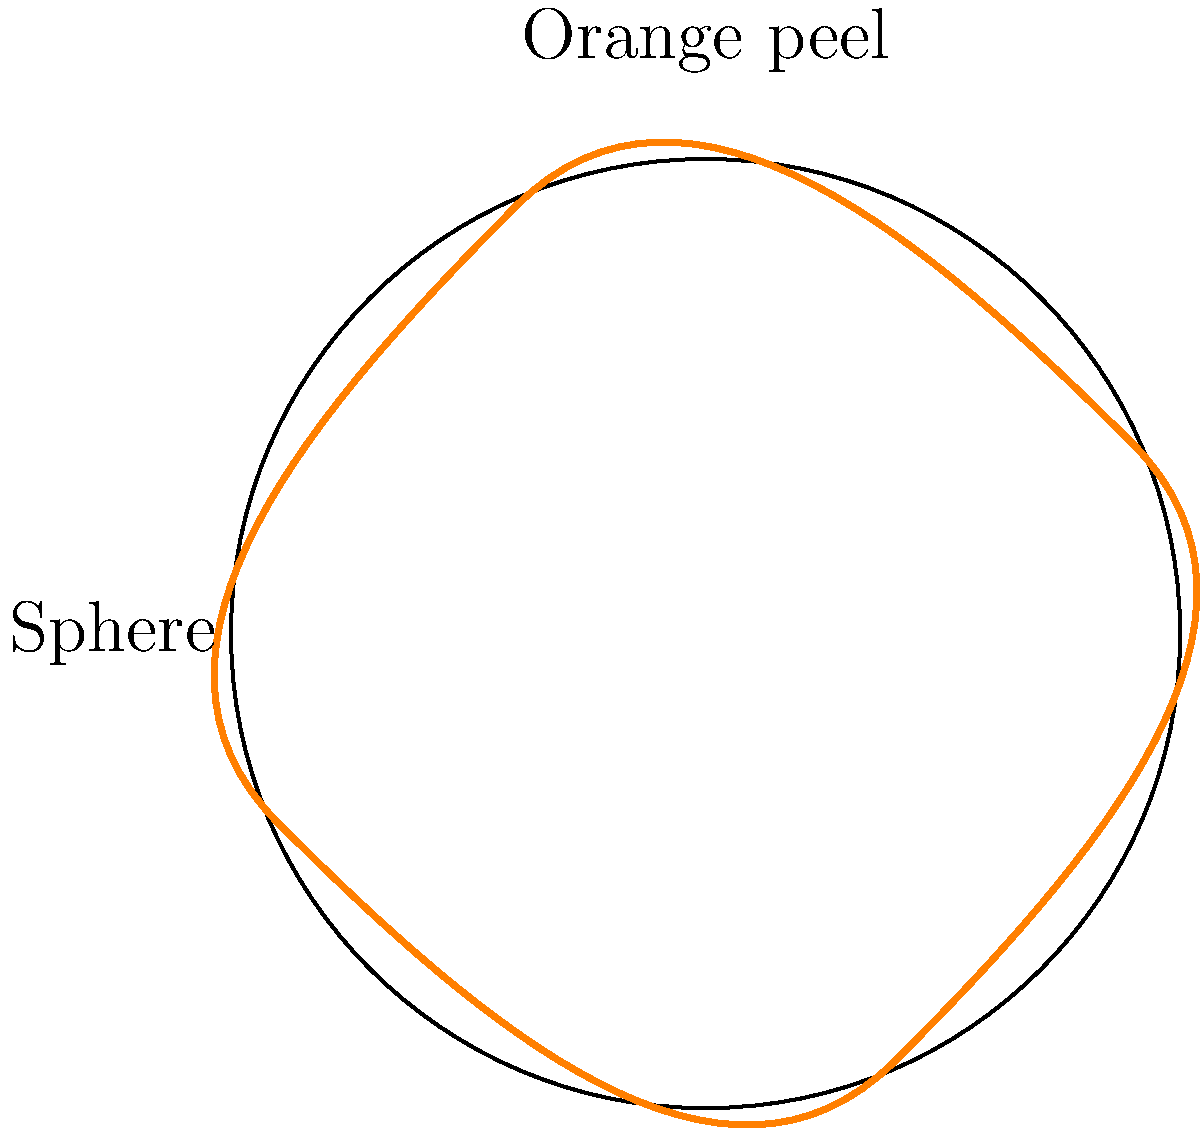You have just peeled an orange and noticed that the peel, when flattened out, forms a shape similar to a circle. How could you use this observation to estimate the surface area of the orange (which is approximately spherical)? Describe a hands-on method to calculate this estimate and explain why it works. To estimate the surface area of the orange using its peel, follow these steps:

1. Carefully peel the orange, trying to keep the peel in one piece.

2. Flatten out the peel on a flat surface, shaping it into a circular form as best as possible.

3. Trace the outline of the flattened peel on a piece of paper.

4. Cut out the traced shape from the paper.

5. Measure the diameter of this paper "peel" using a ruler.

6. Calculate the area of this circular shape using the formula $A = \pi r^2$, where $r$ is half the measured diameter.

This method works because:

a) The surface of a sphere can be approximated by "unwrapping" it into a flat shape.

b) The area of this flat shape is approximately equal to the surface area of the sphere.

c) The surface area of a sphere is given by the formula $SA = 4\pi r^2$, where $r$ is the radius of the sphere.

d) The flattened peel forms a circle with an area of $\pi R^2$, where $R$ is the radius of this circle.

e) The radius $R$ of the flattened peel is approximately twice the radius $r$ of the orange:

   $R \approx 2r$

f) Therefore:
   
   $\pi R^2 \approx \pi (2r)^2 = 4\pi r^2$

This shows that the area of the flattened peel is approximately equal to the surface area of the sphere, validating our estimation method.
Answer: Flatten the orange peel, measure its diameter, calculate the area of the resulting circle: $A = \pi r^2$. 